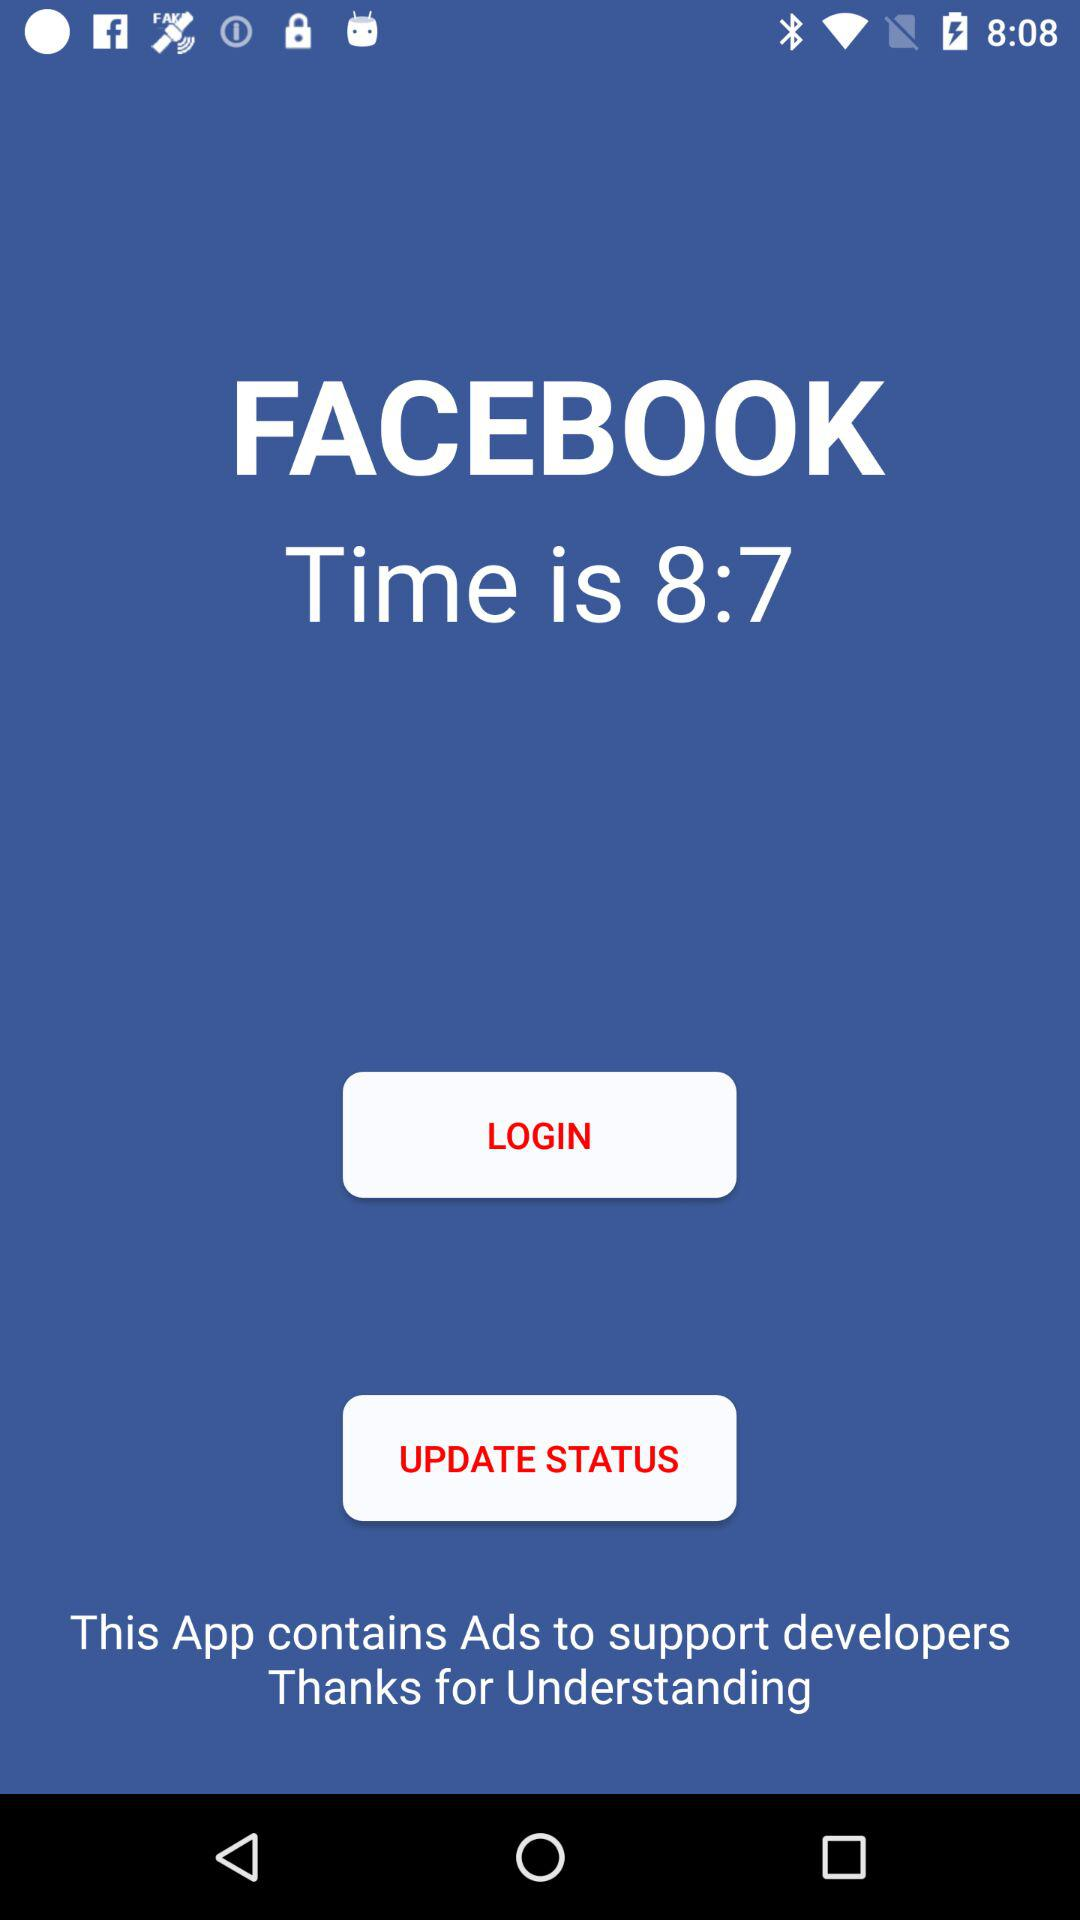What is the application name? The application name is "FACEBOOK". 